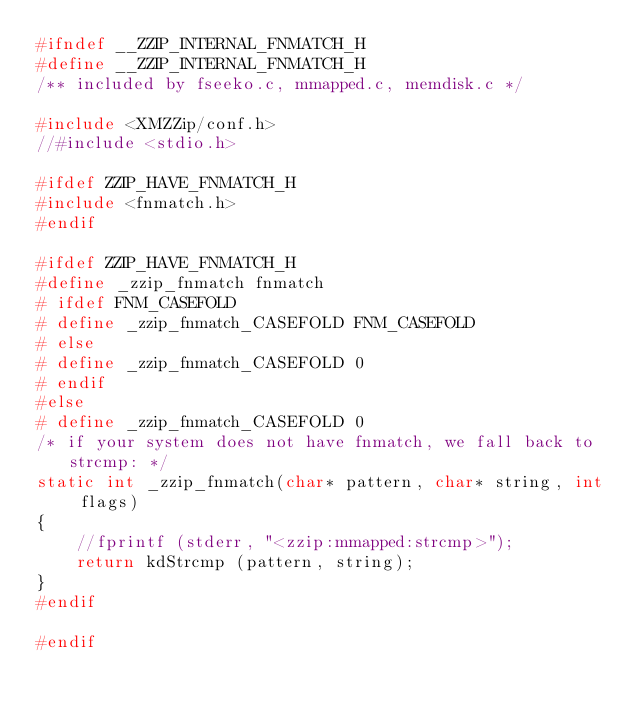<code> <loc_0><loc_0><loc_500><loc_500><_C_>#ifndef __ZZIP_INTERNAL_FNMATCH_H
#define __ZZIP_INTERNAL_FNMATCH_H
/** included by fseeko.c, mmapped.c, memdisk.c */

#include <XMZZip/conf.h>
//#include <stdio.h>

#ifdef ZZIP_HAVE_FNMATCH_H
#include <fnmatch.h>
#endif

#ifdef ZZIP_HAVE_FNMATCH_H
#define _zzip_fnmatch fnmatch
# ifdef FNM_CASEFOLD
# define _zzip_fnmatch_CASEFOLD FNM_CASEFOLD
# else
# define _zzip_fnmatch_CASEFOLD 0
# endif
#else
# define _zzip_fnmatch_CASEFOLD 0
/* if your system does not have fnmatch, we fall back to strcmp: */
static int _zzip_fnmatch(char* pattern, char* string, int flags)
{ 
    //fprintf (stderr, "<zzip:mmapped:strcmp>");
    return kdStrcmp (pattern, string); 
}
#endif

#endif
</code> 